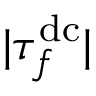<formula> <loc_0><loc_0><loc_500><loc_500>| \tau _ { f } ^ { d c } |</formula> 